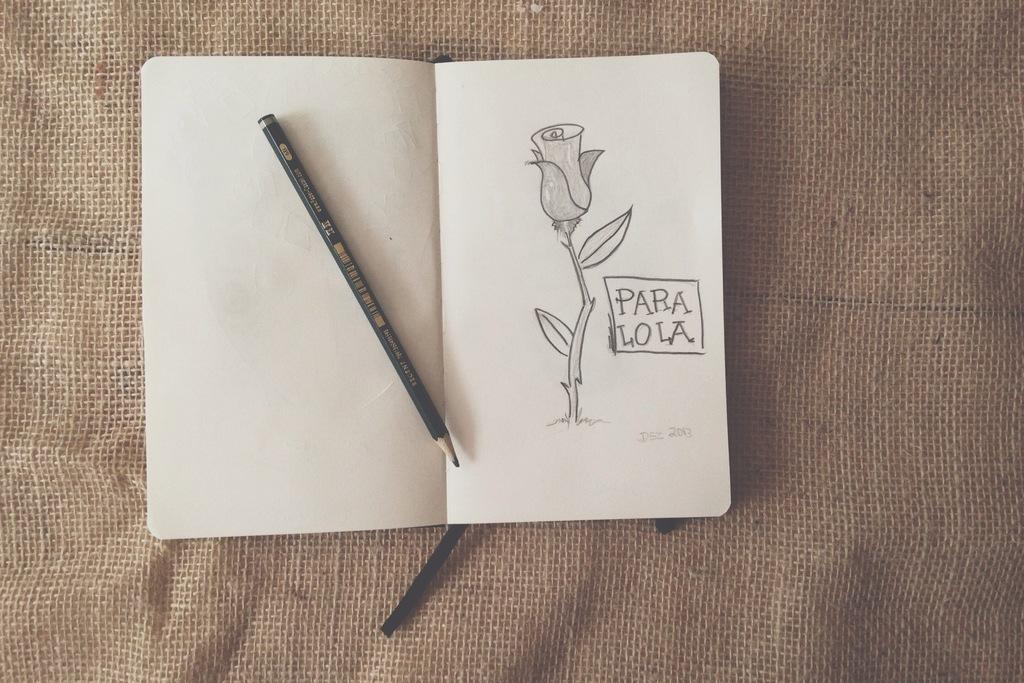What object can be seen in the image that is commonly used for writing? There is a pencil in the image. What is the pencil used for in the image? The pencil is used for drawing a flower on the book. What is the book used for in the image? The book is used for displaying pencil art of a flower and has text written on it. What material can be seen in the background of the image? There is a jute cloth in the background of the image. What type of hate can be seen in the image? There is no hate present in the image; it features a pencil drawing of a flower on a book. What activity is the person in the image participating in? There is no person visible in the image; it only shows a pencil, a book, and a jute cloth in the background. 